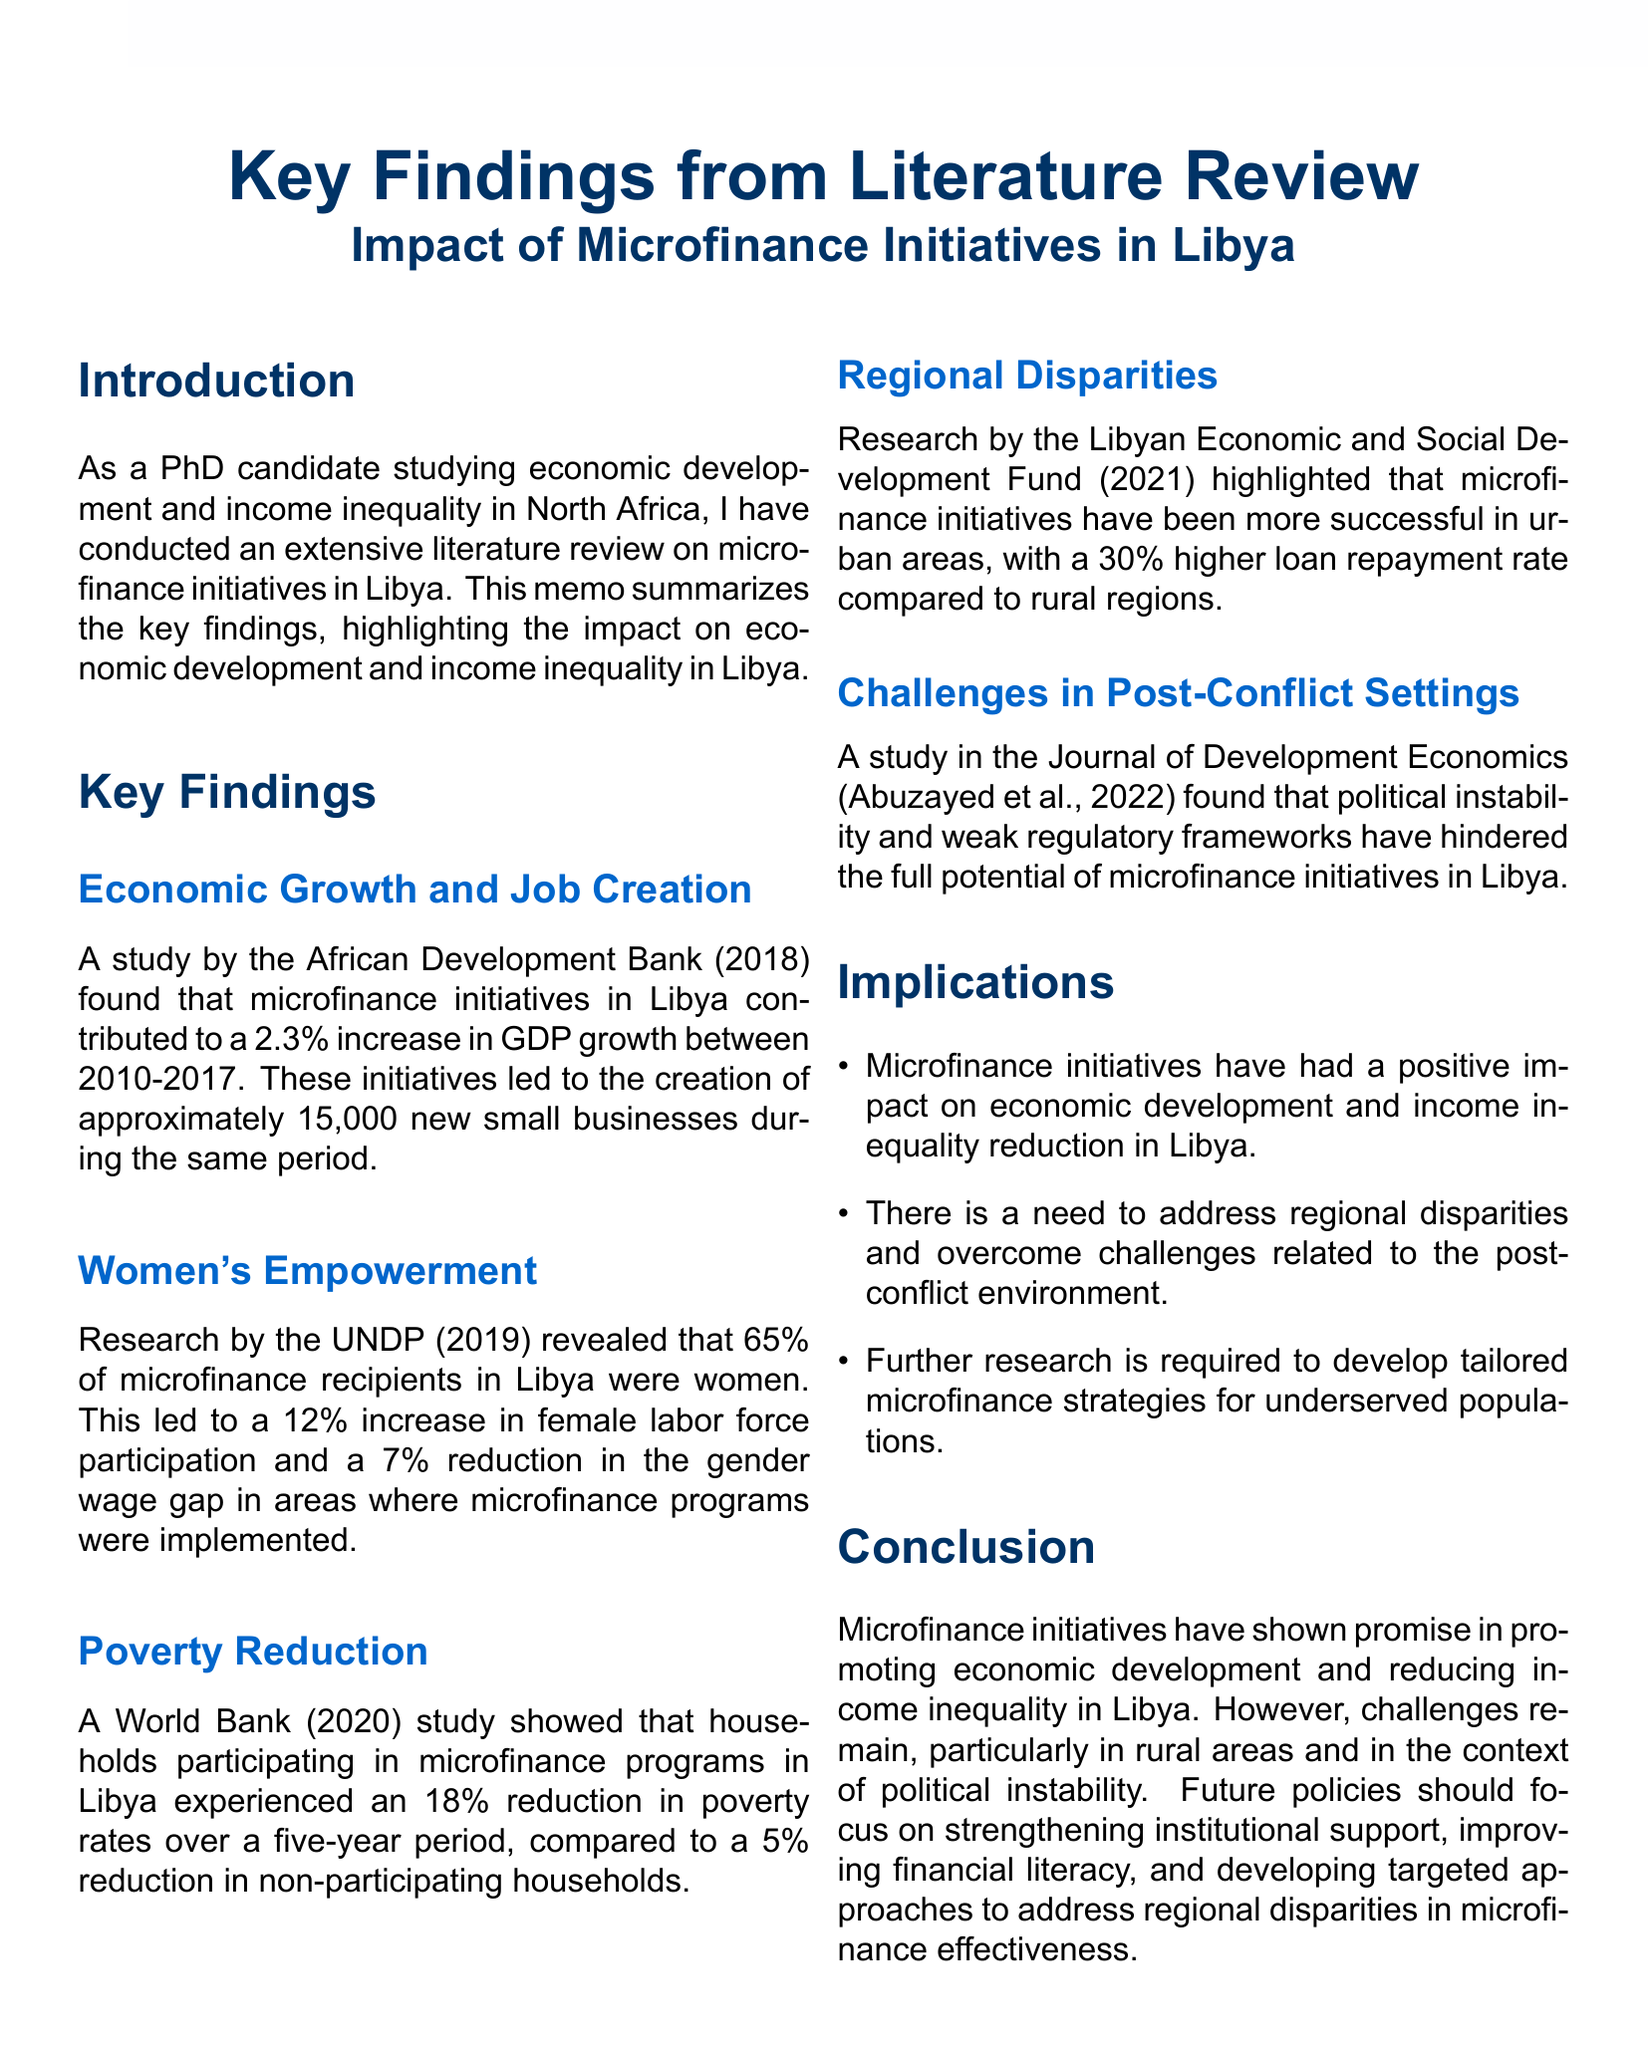what is the percentage increase in GDP growth due to microfinance initiatives in Libya? The African Development Bank study reported a 2.3% increase in GDP growth between 2010-2017 due to microfinance initiatives.
Answer: 2.3% how many new small businesses were created by microfinance initiatives in Libya? The same study by the African Development Bank indicated that approximately 15,000 new small businesses were created during the study period.
Answer: 15,000 what percentage of microfinance recipients in Libya are women? The UNDP research revealed that 65% of the microfinance recipients in Libya were women.
Answer: 65% what was the reduction in poverty rates for households participating in microfinance programs over five years? The World Bank study showed that participating households experienced an 18% reduction in poverty rates.
Answer: 18% what is the loan repayment rate comparison between urban and rural areas in Libya? The Libyan Economic and Social Development Fund research highlighted a 30% higher loan repayment rate in urban areas compared to rural regions.
Answer: 30% what are suggested solutions to improve microfinance initiatives in Libya? The study published in the Journal of Development Economics recommended strengthening institutional support and improving financial literacy.
Answer: strengthening institutional support, improving financial literacy which organization reported challenges faced by microfinance in post-conflict settings? The challenges were reported in a study published in the Journal of Development Economics by Abuzayed et al.
Answer: Journal of Development Economics what is the main conclusion regarding microfinance initiatives in Libya? The conclusion states that microfinance initiatives have shown promise in promoting economic development and reducing income inequality in Libya.
Answer: promise in promoting economic development and reducing income inequality 